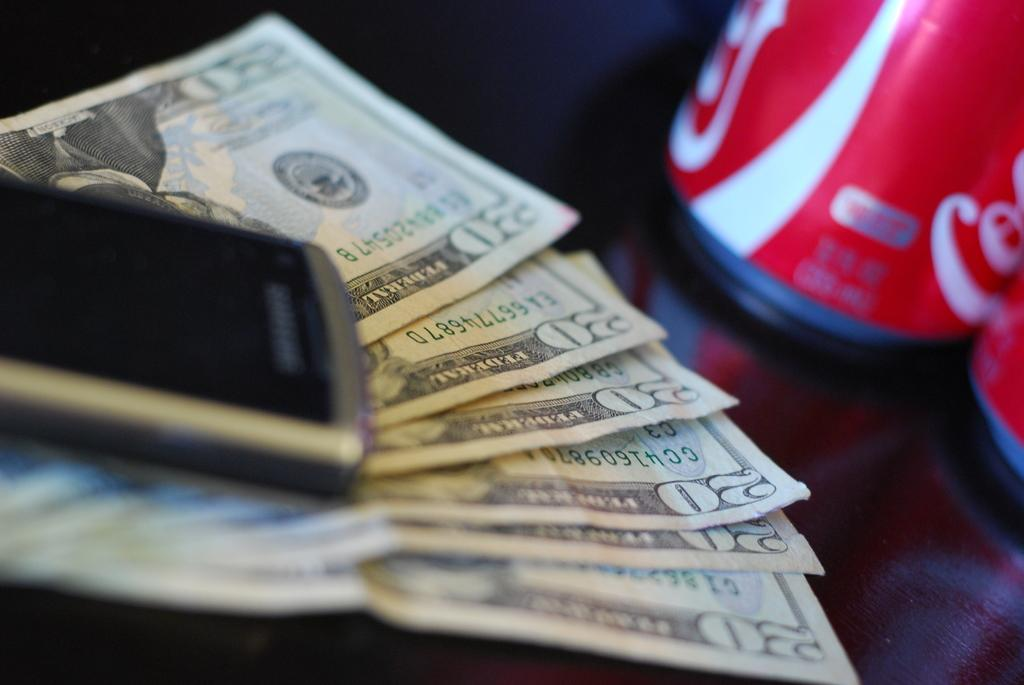<image>
Describe the image concisely. a nokia phone sitting on top of a row of 20 dollar bills 